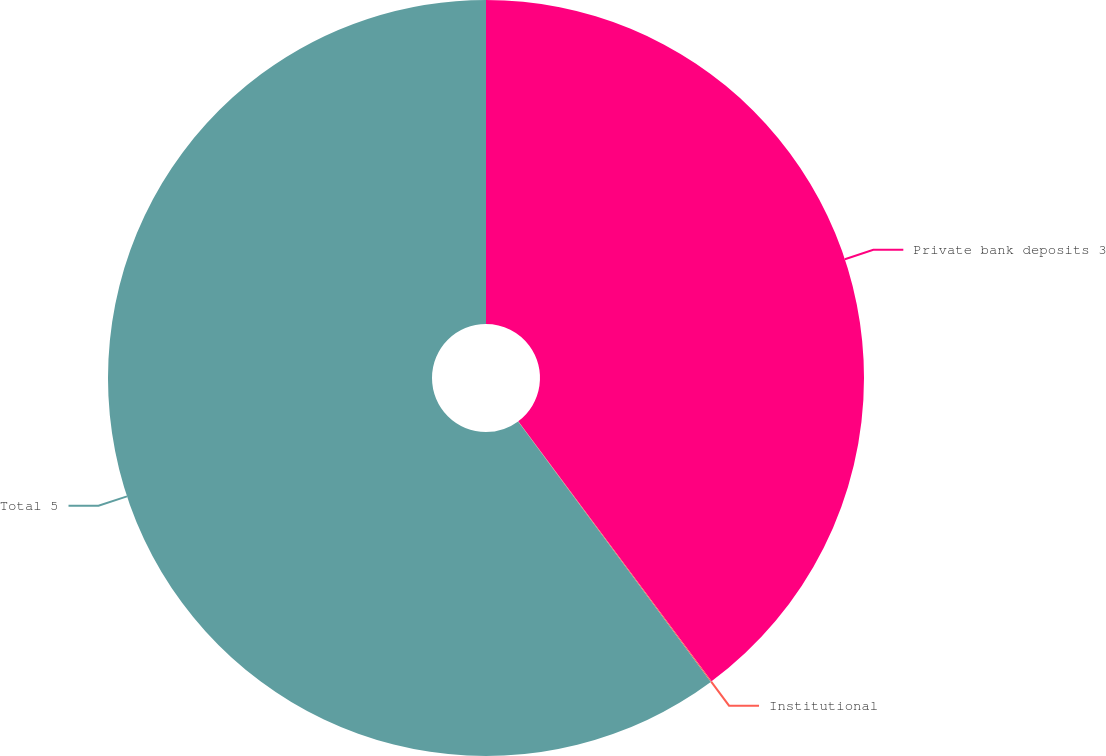Convert chart. <chart><loc_0><loc_0><loc_500><loc_500><pie_chart><fcel>Private bank deposits 3<fcel>Institutional<fcel>Total 5<nl><fcel>39.82%<fcel>0.04%<fcel>60.13%<nl></chart> 